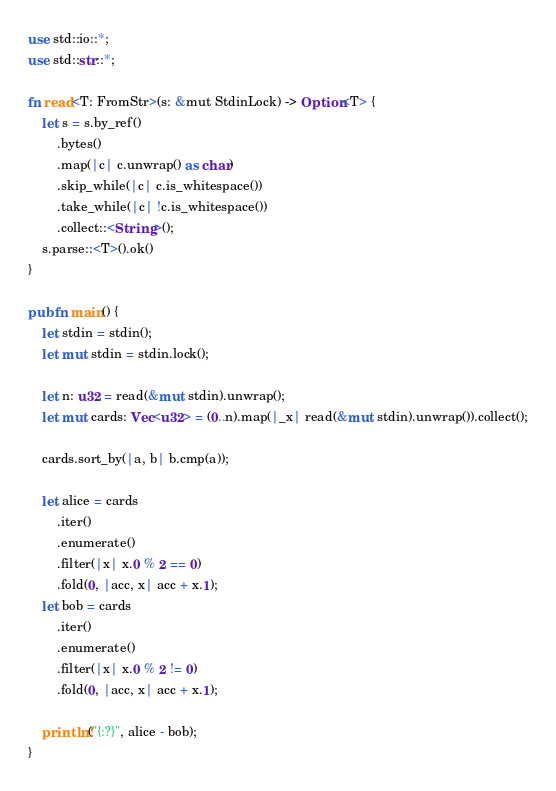Convert code to text. <code><loc_0><loc_0><loc_500><loc_500><_Rust_>use std::io::*;
use std::str::*;

fn read<T: FromStr>(s: &mut StdinLock) -> Option<T> {
    let s = s.by_ref()
        .bytes()
        .map(|c| c.unwrap() as char)
        .skip_while(|c| c.is_whitespace())
        .take_while(|c| !c.is_whitespace())
        .collect::<String>();
    s.parse::<T>().ok()
}

pub fn main() {
    let stdin = stdin();
    let mut stdin = stdin.lock();

    let n: u32 = read(&mut stdin).unwrap();
    let mut cards: Vec<u32> = (0..n).map(|_x| read(&mut stdin).unwrap()).collect();

    cards.sort_by(|a, b| b.cmp(a));

    let alice = cards
        .iter()
        .enumerate()
        .filter(|x| x.0 % 2 == 0)
        .fold(0, |acc, x| acc + x.1);
    let bob = cards
        .iter()
        .enumerate()
        .filter(|x| x.0 % 2 != 0)
        .fold(0, |acc, x| acc + x.1);

    println!("{:?}", alice - bob);
}
</code> 